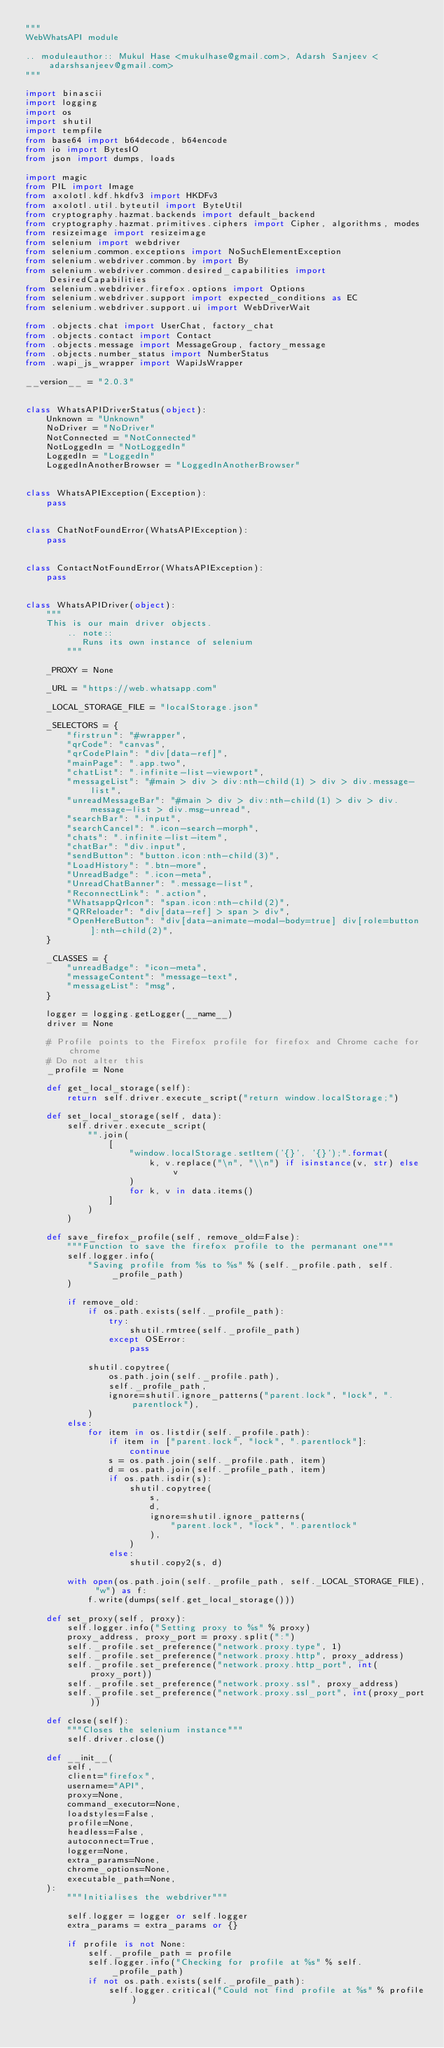<code> <loc_0><loc_0><loc_500><loc_500><_Python_>"""
WebWhatsAPI module

.. moduleauthor:: Mukul Hase <mukulhase@gmail.com>, Adarsh Sanjeev <adarshsanjeev@gmail.com>
"""

import binascii
import logging
import os
import shutil
import tempfile
from base64 import b64decode, b64encode
from io import BytesIO
from json import dumps, loads

import magic
from PIL import Image
from axolotl.kdf.hkdfv3 import HKDFv3
from axolotl.util.byteutil import ByteUtil
from cryptography.hazmat.backends import default_backend
from cryptography.hazmat.primitives.ciphers import Cipher, algorithms, modes
from resizeimage import resizeimage
from selenium import webdriver
from selenium.common.exceptions import NoSuchElementException
from selenium.webdriver.common.by import By
from selenium.webdriver.common.desired_capabilities import DesiredCapabilities
from selenium.webdriver.firefox.options import Options
from selenium.webdriver.support import expected_conditions as EC
from selenium.webdriver.support.ui import WebDriverWait

from .objects.chat import UserChat, factory_chat
from .objects.contact import Contact
from .objects.message import MessageGroup, factory_message
from .objects.number_status import NumberStatus
from .wapi_js_wrapper import WapiJsWrapper

__version__ = "2.0.3"


class WhatsAPIDriverStatus(object):
    Unknown = "Unknown"
    NoDriver = "NoDriver"
    NotConnected = "NotConnected"
    NotLoggedIn = "NotLoggedIn"
    LoggedIn = "LoggedIn"
    LoggedInAnotherBrowser = "LoggedInAnotherBrowser"


class WhatsAPIException(Exception):
    pass


class ChatNotFoundError(WhatsAPIException):
    pass


class ContactNotFoundError(WhatsAPIException):
    pass


class WhatsAPIDriver(object):
    """
    This is our main driver objects.
        .. note::
           Runs its own instance of selenium
        """

    _PROXY = None

    _URL = "https://web.whatsapp.com"

    _LOCAL_STORAGE_FILE = "localStorage.json"

    _SELECTORS = {
        "firstrun": "#wrapper",
        "qrCode": "canvas",
        "qrCodePlain": "div[data-ref]",
        "mainPage": ".app.two",
        "chatList": ".infinite-list-viewport",
        "messageList": "#main > div > div:nth-child(1) > div > div.message-list",
        "unreadMessageBar": "#main > div > div:nth-child(1) > div > div.message-list > div.msg-unread",
        "searchBar": ".input",
        "searchCancel": ".icon-search-morph",
        "chats": ".infinite-list-item",
        "chatBar": "div.input",
        "sendButton": "button.icon:nth-child(3)",
        "LoadHistory": ".btn-more",
        "UnreadBadge": ".icon-meta",
        "UnreadChatBanner": ".message-list",
        "ReconnectLink": ".action",
        "WhatsappQrIcon": "span.icon:nth-child(2)",
        "QRReloader": "div[data-ref] > span > div",
        "OpenHereButton": "div[data-animate-modal-body=true] div[role=button]:nth-child(2)",
    }

    _CLASSES = {
        "unreadBadge": "icon-meta",
        "messageContent": "message-text",
        "messageList": "msg",
    }

    logger = logging.getLogger(__name__)
    driver = None

    # Profile points to the Firefox profile for firefox and Chrome cache for chrome
    # Do not alter this
    _profile = None

    def get_local_storage(self):
        return self.driver.execute_script("return window.localStorage;")

    def set_local_storage(self, data):
        self.driver.execute_script(
            "".join(
                [
                    "window.localStorage.setItem('{}', '{}');".format(
                        k, v.replace("\n", "\\n") if isinstance(v, str) else v
                    )
                    for k, v in data.items()
                ]
            )
        )

    def save_firefox_profile(self, remove_old=False):
        """Function to save the firefox profile to the permanant one"""
        self.logger.info(
            "Saving profile from %s to %s" % (self._profile.path, self._profile_path)
        )

        if remove_old:
            if os.path.exists(self._profile_path):
                try:
                    shutil.rmtree(self._profile_path)
                except OSError:
                    pass

            shutil.copytree(
                os.path.join(self._profile.path),
                self._profile_path,
                ignore=shutil.ignore_patterns("parent.lock", "lock", ".parentlock"),
            )
        else:
            for item in os.listdir(self._profile.path):
                if item in ["parent.lock", "lock", ".parentlock"]:
                    continue
                s = os.path.join(self._profile.path, item)
                d = os.path.join(self._profile_path, item)
                if os.path.isdir(s):
                    shutil.copytree(
                        s,
                        d,
                        ignore=shutil.ignore_patterns(
                            "parent.lock", "lock", ".parentlock"
                        ),
                    )
                else:
                    shutil.copy2(s, d)

        with open(os.path.join(self._profile_path, self._LOCAL_STORAGE_FILE), "w") as f:
            f.write(dumps(self.get_local_storage()))

    def set_proxy(self, proxy):
        self.logger.info("Setting proxy to %s" % proxy)
        proxy_address, proxy_port = proxy.split(":")
        self._profile.set_preference("network.proxy.type", 1)
        self._profile.set_preference("network.proxy.http", proxy_address)
        self._profile.set_preference("network.proxy.http_port", int(proxy_port))
        self._profile.set_preference("network.proxy.ssl", proxy_address)
        self._profile.set_preference("network.proxy.ssl_port", int(proxy_port))

    def close(self):
        """Closes the selenium instance"""
        self.driver.close()

    def __init__(
        self,
        client="firefox",
        username="API",
        proxy=None,
        command_executor=None,
        loadstyles=False,
        profile=None,
        headless=False,
        autoconnect=True,
        logger=None,
        extra_params=None,
        chrome_options=None,
        executable_path=None,
    ):
        """Initialises the webdriver"""

        self.logger = logger or self.logger
        extra_params = extra_params or {}

        if profile is not None:
            self._profile_path = profile
            self.logger.info("Checking for profile at %s" % self._profile_path)
            if not os.path.exists(self._profile_path):
                self.logger.critical("Could not find profile at %s" % profile)</code> 